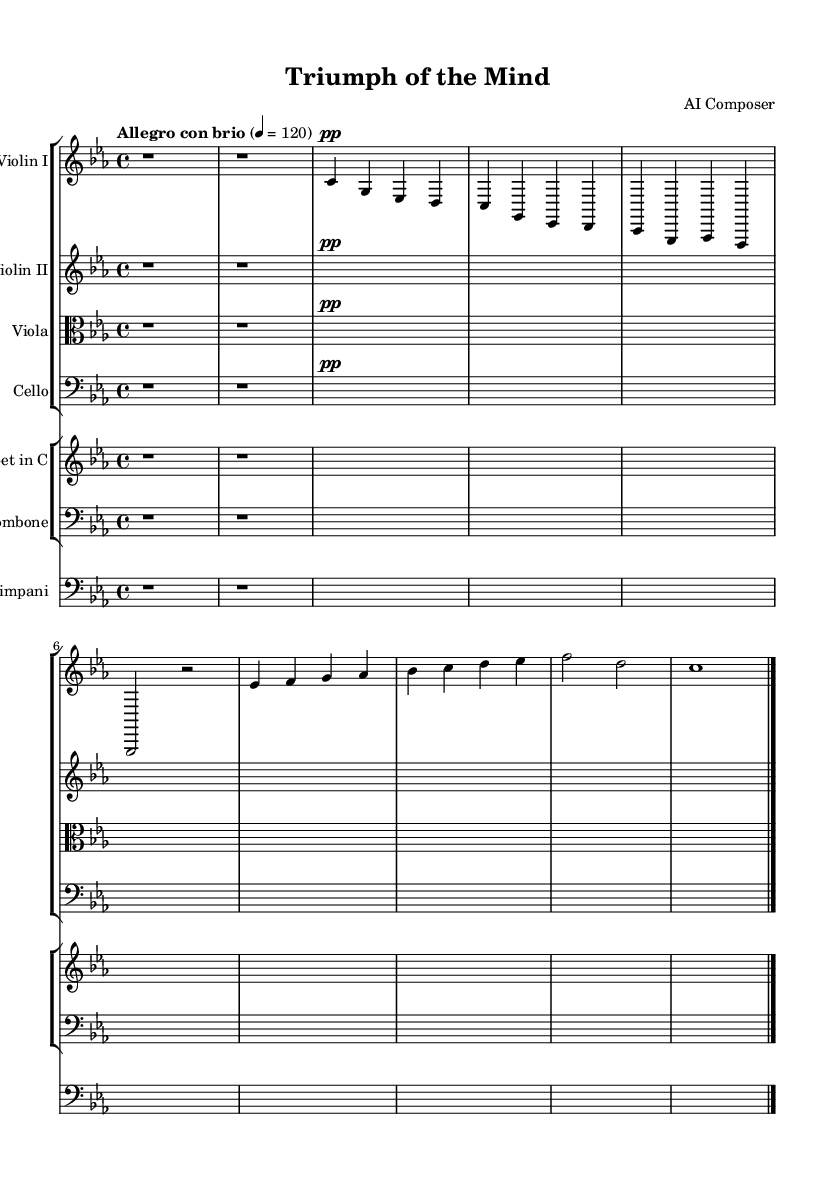What is the key signature of this music? The key signature is C minor, which is indicated by three flats (B flat, E flat, and A flat) on the staff.
Answer: C minor What is the time signature of this piece? The time signature shown at the beginning of the music is 4/4, meaning there are four beats in each measure and a quarter note receives one beat.
Answer: 4/4 What is the tempo marking for this piece? The tempo marking is "Allegro con brio", which translates to a fast and lively pace, typically around 120 beats per minute.
Answer: Allegro con brio How many staff groups are present in the score? The score contains two staff groups, one for strings and one for brass and timpani. Each group contains multiple individual staves for different instruments.
Answer: Two Which instruments are featured in the first staff group? The first staff group includes Violin I, Violin II, Viola, and Cello, which are typical string instruments used in orchestral settings.
Answer: Violin I, Violin II, Viola, Cello What is the primary theme in this piece? The primary theme is represented by the melodic lines in the violin parts, particularly in measures that contain the sequences of notes defining theme A and theme B.
Answer: Theme A, Theme B Is there a dynamic marking in the introduction of the piece? Yes, the dynamic marking for the introduction specifies "pp", which stands for pianississimo, meaning very very soft.
Answer: pp 